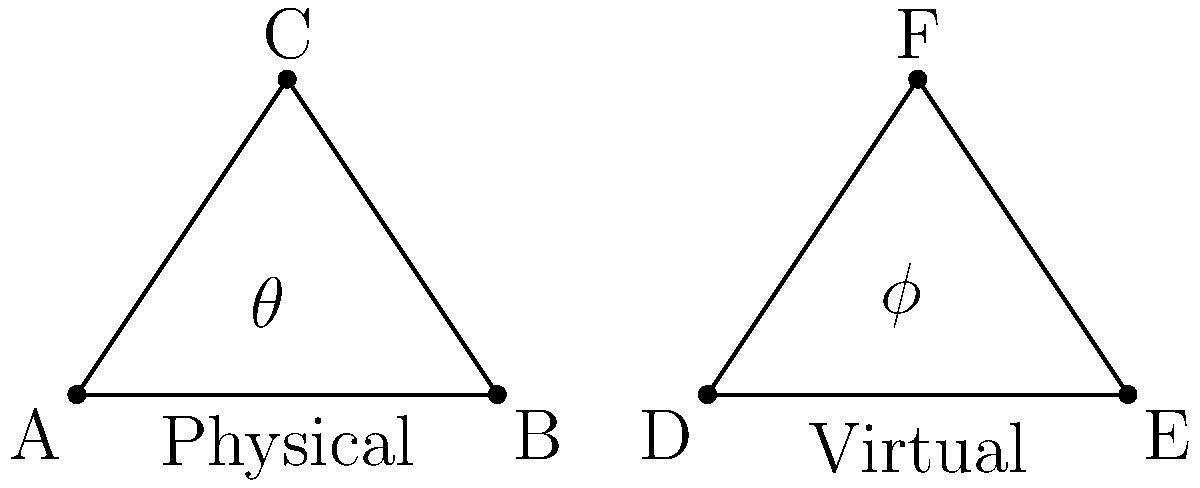In the diagram, two triangles represent character movement paths in physical theater blocking (ABC) and virtual character animation (DEF). If the angle $\theta$ in the physical theater blocking is 60°, and the virtual animation angle $\phi$ is 1.5 times larger, what is the measure of angle $\phi$? To solve this problem, let's follow these steps:

1. Understand the given information:
   - Angle $\theta$ in the physical theater blocking (triangle ABC) is 60°.
   - Angle $\phi$ in the virtual animation (triangle DEF) is 1.5 times larger than $\theta$.

2. Set up an equation to represent the relationship between $\theta$ and $\phi$:
   $\phi = 1.5 \times \theta$

3. Substitute the known value of $\theta$:
   $\phi = 1.5 \times 60°$

4. Perform the multiplication:
   $\phi = 90°$

Therefore, the measure of angle $\phi$ in the virtual animation triangle is 90°.
Answer: 90° 